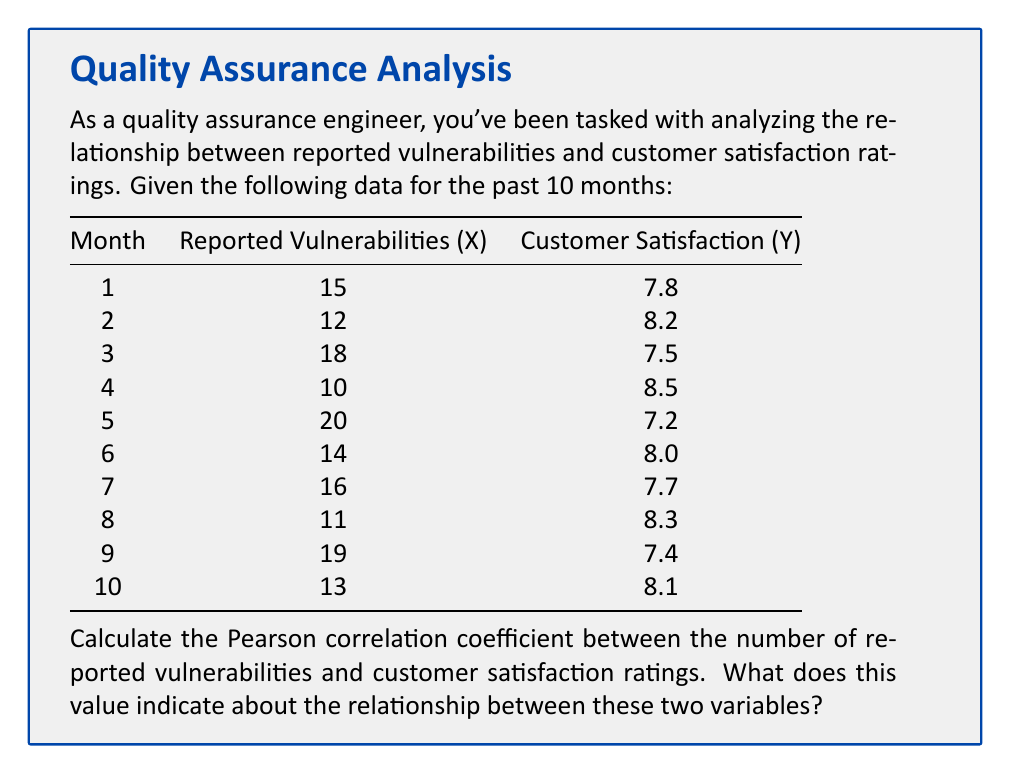Could you help me with this problem? To calculate the Pearson correlation coefficient (r), we'll use the formula:

$$ r = \frac{\sum_{i=1}^{n} (x_i - \bar{x})(y_i - \bar{y})}{\sqrt{\sum_{i=1}^{n} (x_i - \bar{x})^2 \sum_{i=1}^{n} (y_i - \bar{y})^2}} $$

Step 1: Calculate the means of X and Y.
$\bar{x} = \frac{15 + 12 + 18 + 10 + 20 + 14 + 16 + 11 + 19 + 13}{10} = 14.8$
$\bar{y} = \frac{7.8 + 8.2 + 7.5 + 8.5 + 7.2 + 8.0 + 7.7 + 8.3 + 7.4 + 8.1}{10} = 7.87$

Step 2: Calculate $(x_i - \bar{x})$, $(y_i - \bar{y})$, $(x_i - \bar{x})^2$, $(y_i - \bar{y})^2$, and $(x_i - \bar{x})(y_i - \bar{y})$ for each data point.

Step 3: Sum up the values calculated in Step 2.
$\sum (x_i - \bar{x})(y_i - \bar{y}) = -24.86$
$\sum (x_i - \bar{x})^2 = 122.8$
$\sum (y_i - \bar{y})^2 = 1.5861$

Step 4: Apply the formula.
$$ r = \frac{-24.86}{\sqrt{122.8 \times 1.5861}} = -0.9954 $$

The Pearson correlation coefficient is approximately -0.9954.

This value indicates a very strong negative correlation between the number of reported vulnerabilities and customer satisfaction ratings. As the number of reported vulnerabilities increases, customer satisfaction tends to decrease, and vice versa. The relationship is almost perfectly linear and inverse, as the coefficient is very close to -1.
Answer: $r \approx -0.9954$, indicating a very strong negative correlation 